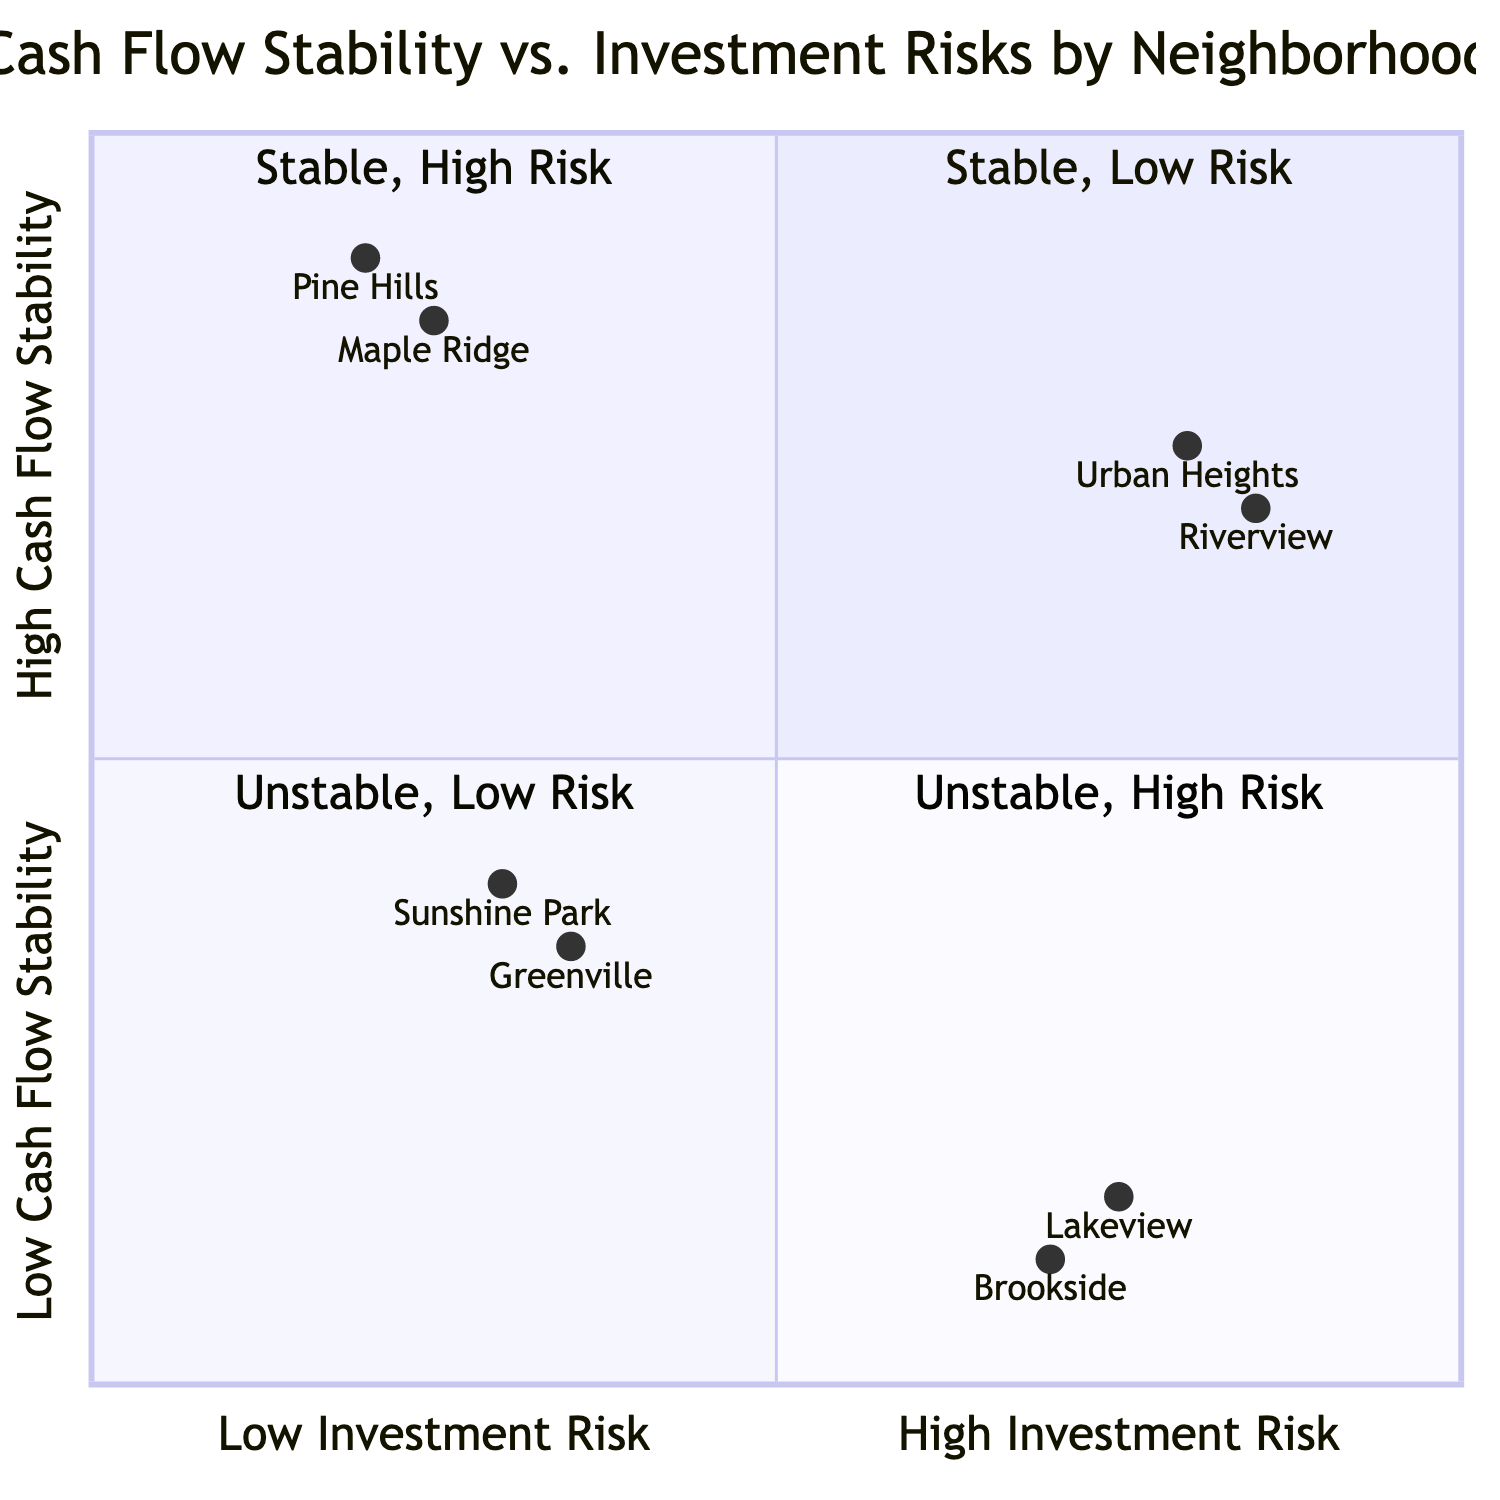What neighborhood has the highest average rent price? In the diagram, the neighborhoods are plotted based on their average rent prices. Comparing the average rent prices listed, Urban Heights has the highest average rent price of 2200.
Answer: Urban Heights Which neighborhood has the lowest vacancy rate? The neighborhoods are characterized by their vacancy rates as well. The neighborhood with the lowest vacancy rate is Pine Hills, which has a vacancy rate of 5.
Answer: Pine Hills How many neighborhoods are in the "High Cash Flow Stability, Low Investment Risk" quadrant? The diagram contains multiple quadrants, and when counting the neighborhoods in the "High Cash Flow Stability, Low Investment Risk" quadrant, there are two neighborhoods: Pine Hills and Maple Ridge.
Answer: 2 What is the crime rate for the neighborhoods in the "Low Cash Flow Stability, High Investment Risk" quadrant? Analyzing the crime rates for the neighborhoods in this quadrant, both Brookside and Lakeview have a crime rate categorized as "High."
Answer: High Which neighborhood has the lowest average rent price in the "Low Cash Flow Stability, High Investment Risk" quadrant? Within the "Low Cash Flow Stability, High Investment Risk" quadrant, the average rent prices are compared, and Brookside has the lowest average rent price of 800.
Answer: Brookside What is the property tax rate for Maple Ridge? The property tax rates are additional characteristics of the neighborhoods and specifically for Maple Ridge, the property tax rate is recorded as 1.1.
Answer: 1.1 In which quadrant is Sunshine Park located? According to the provided data, Sunshine Park is listed under the quadrant that indicates "Low Cash Flow Stability, Low Investment Risk." Therefore, it is located in that specific quadrant.
Answer: Low Cash Flow Stability, Low Investment Risk Which neighborhood has a higher average rent price, Riverview or Greenville? By comparing the average rent prices of both neighborhoods, Riverview has an average rent price of 2100, while Greenville has an average rent price of 1000. This means Riverview has a higher rent price than Greenville.
Answer: Riverview What is the average rent price for Pine Hills? Referring to the data on Pine Hills, the average rent price is given as 2000, which is a straightforward figure we can extract from the diagram.
Answer: 2000 